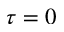Convert formula to latex. <formula><loc_0><loc_0><loc_500><loc_500>\tau = 0</formula> 